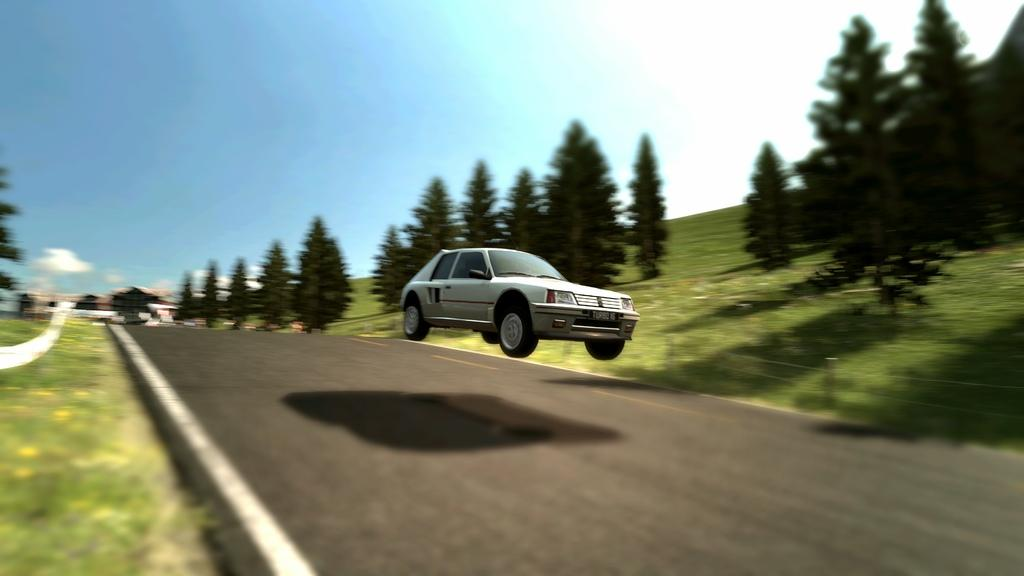What is the main subject of the image? There is a car on the road in the image. What type of vegetation can be seen in the image? There are trees and grass in the image. What is the arm of the crow doing in the image? There is no crow or arm present in the image. 